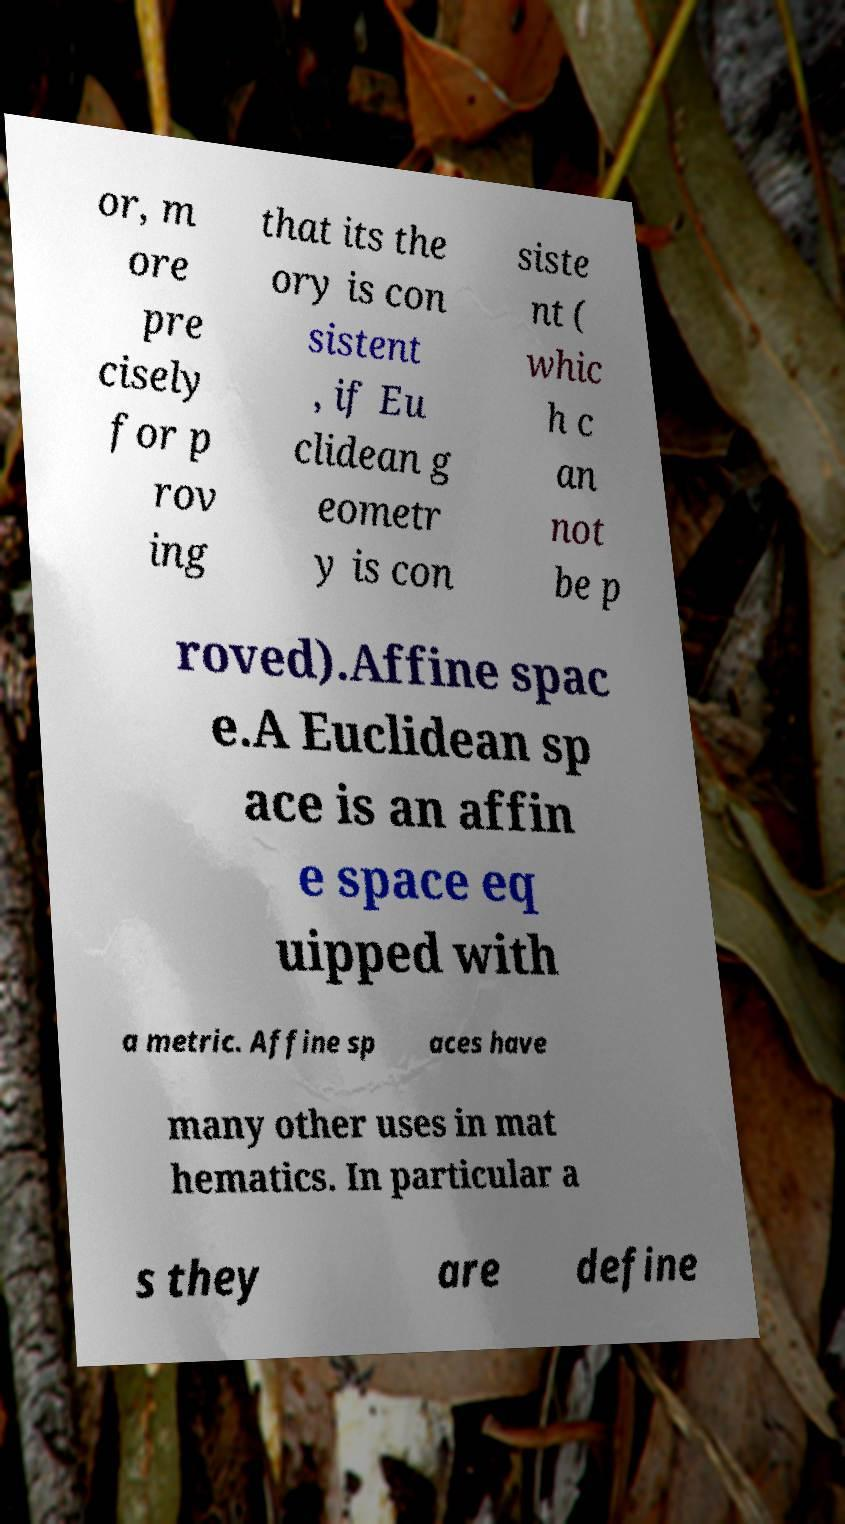There's text embedded in this image that I need extracted. Can you transcribe it verbatim? or, m ore pre cisely for p rov ing that its the ory is con sistent , if Eu clidean g eometr y is con siste nt ( whic h c an not be p roved).Affine spac e.A Euclidean sp ace is an affin e space eq uipped with a metric. Affine sp aces have many other uses in mat hematics. In particular a s they are define 